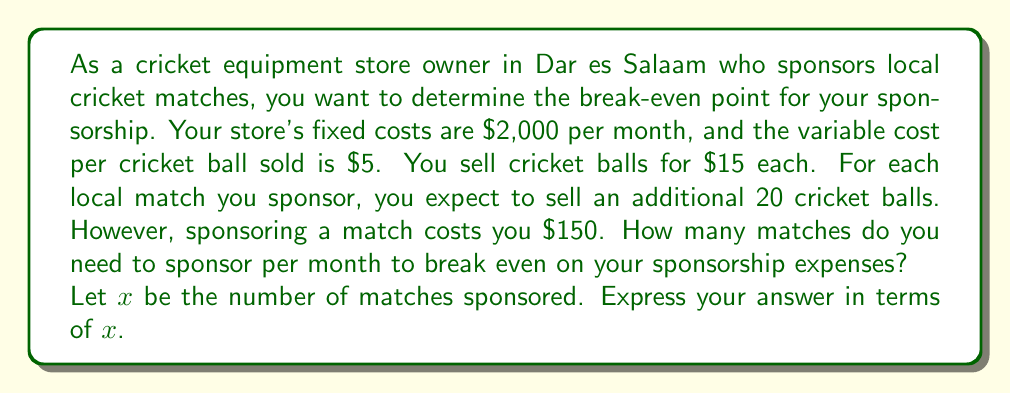Teach me how to tackle this problem. To solve this problem, we need to set up a linear equation that represents the break-even point. At this point, the total revenue equals the total costs.

1. Let's define our variables:
   $x$ = number of matches sponsored
   
2. Calculate the revenue:
   Revenue from additional ball sales = $15 \times 20x = 300x$

3. Calculate the costs:
   Fixed costs = $2,000
   Variable costs for additional balls = $5 \times 20x = 100x$
   Sponsorship costs = $150x$
   Total costs = $2,000 + 100x + 150x = 2,000 + 250x$

4. Set up the break-even equation:
   Revenue = Total costs
   $300x = 2,000 + 250x$

5. Solve for $x$:
   $300x - 250x = 2,000$
   $50x = 2,000$
   $x = \frac{2,000}{50} = 40$

Therefore, you need to sponsor 40 matches per month to break even on your sponsorship expenses.

To verify:
Revenue: $300 \times 40 = 12,000$
Costs: $2,000 + 250 \times 40 = 12,000$

The revenue and costs are equal, confirming the break-even point.
Answer: The break-even point is 40 matches per month. 